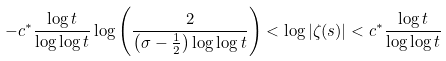Convert formula to latex. <formula><loc_0><loc_0><loc_500><loc_500>- c ^ { * } \frac { \log t } { \log \log t } \log \left ( \frac { 2 } { \left ( \sigma - \frac { 1 } { 2 } \right ) \log \log t } \right ) < \log | \zeta ( s ) | < c ^ { * } \frac { \log t } { \log \log t }</formula> 